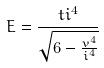<formula> <loc_0><loc_0><loc_500><loc_500>E = \frac { t i ^ { 4 } } { \sqrt { 6 - \frac { v ^ { 4 } } { i ^ { 4 } } } }</formula> 